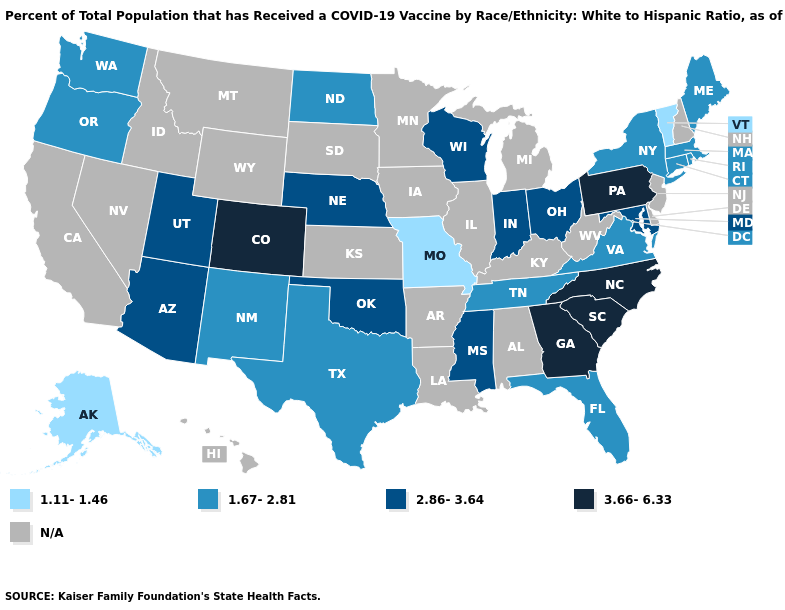Name the states that have a value in the range 1.67-2.81?
Concise answer only. Connecticut, Florida, Maine, Massachusetts, New Mexico, New York, North Dakota, Oregon, Rhode Island, Tennessee, Texas, Virginia, Washington. Name the states that have a value in the range N/A?
Concise answer only. Alabama, Arkansas, California, Delaware, Hawaii, Idaho, Illinois, Iowa, Kansas, Kentucky, Louisiana, Michigan, Minnesota, Montana, Nevada, New Hampshire, New Jersey, South Dakota, West Virginia, Wyoming. What is the lowest value in the MidWest?
Quick response, please. 1.11-1.46. What is the value of Iowa?
Be succinct. N/A. Which states have the highest value in the USA?
Write a very short answer. Colorado, Georgia, North Carolina, Pennsylvania, South Carolina. Name the states that have a value in the range 2.86-3.64?
Quick response, please. Arizona, Indiana, Maryland, Mississippi, Nebraska, Ohio, Oklahoma, Utah, Wisconsin. What is the value of Arkansas?
Answer briefly. N/A. Among the states that border Wyoming , does Colorado have the highest value?
Keep it brief. Yes. Name the states that have a value in the range 2.86-3.64?
Give a very brief answer. Arizona, Indiana, Maryland, Mississippi, Nebraska, Ohio, Oklahoma, Utah, Wisconsin. What is the value of Michigan?
Quick response, please. N/A. Does Nebraska have the lowest value in the MidWest?
Be succinct. No. Which states have the lowest value in the USA?
Be succinct. Alaska, Missouri, Vermont. Name the states that have a value in the range 2.86-3.64?
Write a very short answer. Arizona, Indiana, Maryland, Mississippi, Nebraska, Ohio, Oklahoma, Utah, Wisconsin. Among the states that border Wyoming , does Utah have the lowest value?
Be succinct. Yes. Is the legend a continuous bar?
Quick response, please. No. 